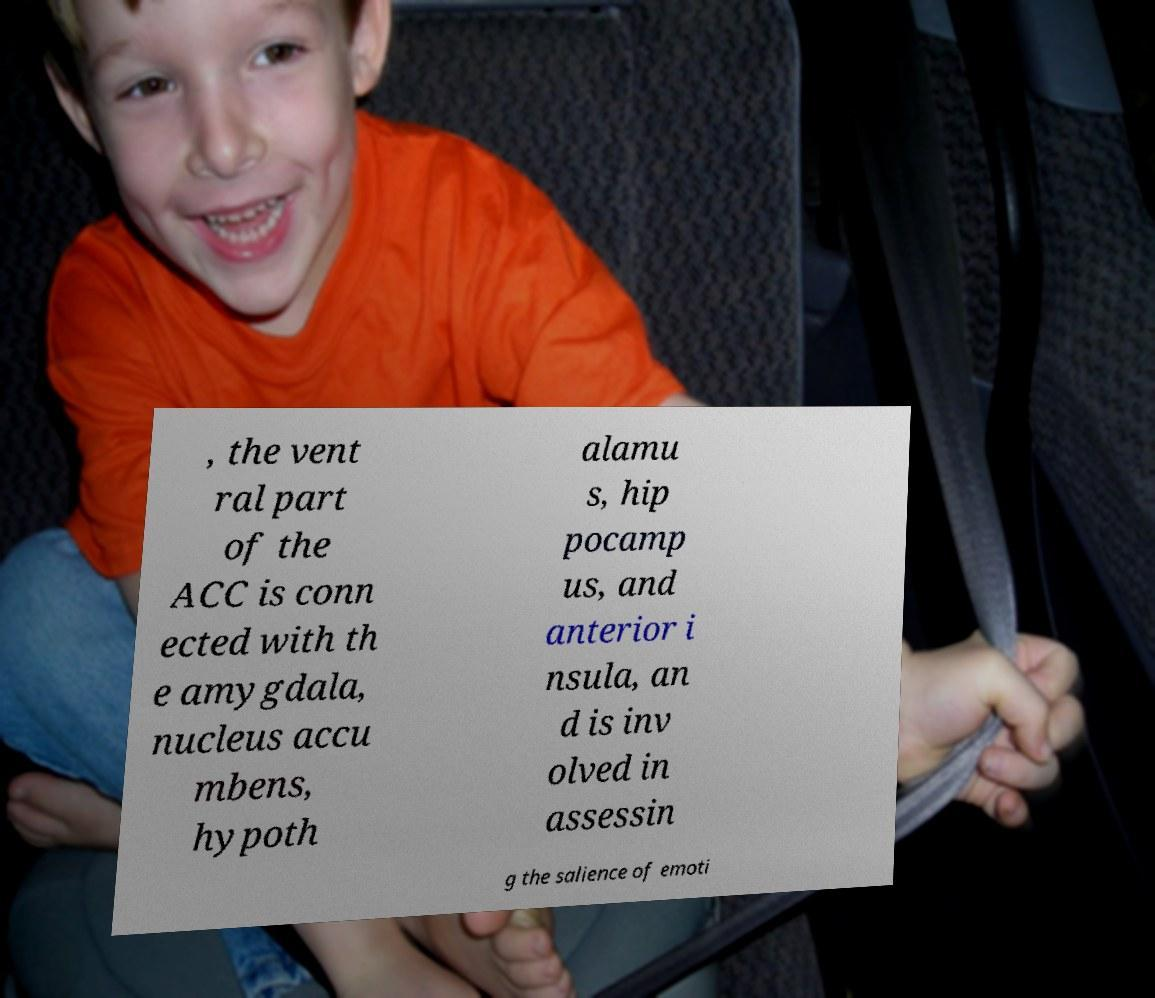What messages or text are displayed in this image? I need them in a readable, typed format. , the vent ral part of the ACC is conn ected with th e amygdala, nucleus accu mbens, hypoth alamu s, hip pocamp us, and anterior i nsula, an d is inv olved in assessin g the salience of emoti 